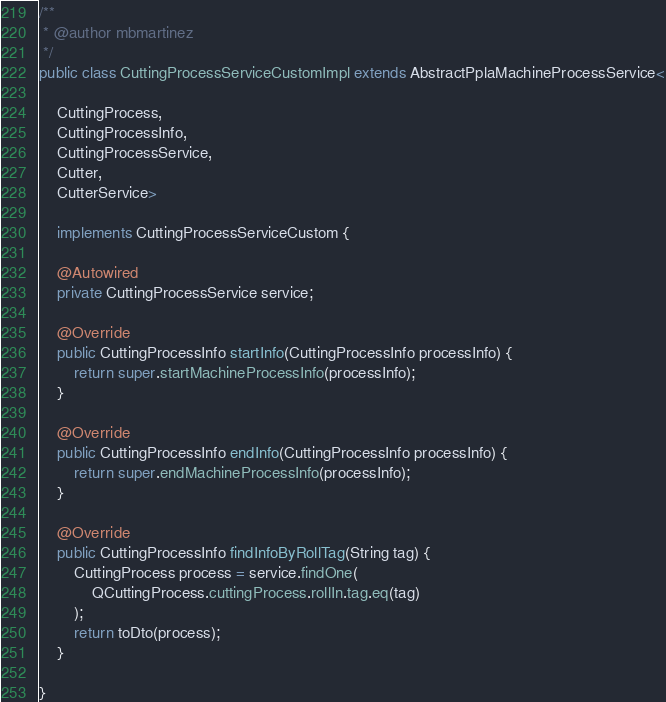<code> <loc_0><loc_0><loc_500><loc_500><_Java_>/**
 * @author mbmartinez
 */
public class CuttingProcessServiceCustomImpl extends AbstractPplaMachineProcessService<

    CuttingProcess, 
    CuttingProcessInfo, 
    CuttingProcessService,
    Cutter,
    CutterService>

    implements CuttingProcessServiceCustom {

    @Autowired
    private CuttingProcessService service;

    @Override
    public CuttingProcessInfo startInfo(CuttingProcessInfo processInfo) {
        return super.startMachineProcessInfo(processInfo);
    }

    @Override
    public CuttingProcessInfo endInfo(CuttingProcessInfo processInfo) {
        return super.endMachineProcessInfo(processInfo);
    }

    @Override
    public CuttingProcessInfo findInfoByRollTag(String tag) {
        CuttingProcess process = service.findOne(
            QCuttingProcess.cuttingProcess.rollIn.tag.eq(tag)
        );
        return toDto(process);
    }

}
</code> 